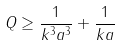<formula> <loc_0><loc_0><loc_500><loc_500>Q \geq \frac { 1 } { k ^ { 3 } a ^ { 3 } } + \frac { 1 } { k a }</formula> 